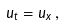Convert formula to latex. <formula><loc_0><loc_0><loc_500><loc_500>u _ { t } = u _ { x } \, ,</formula> 